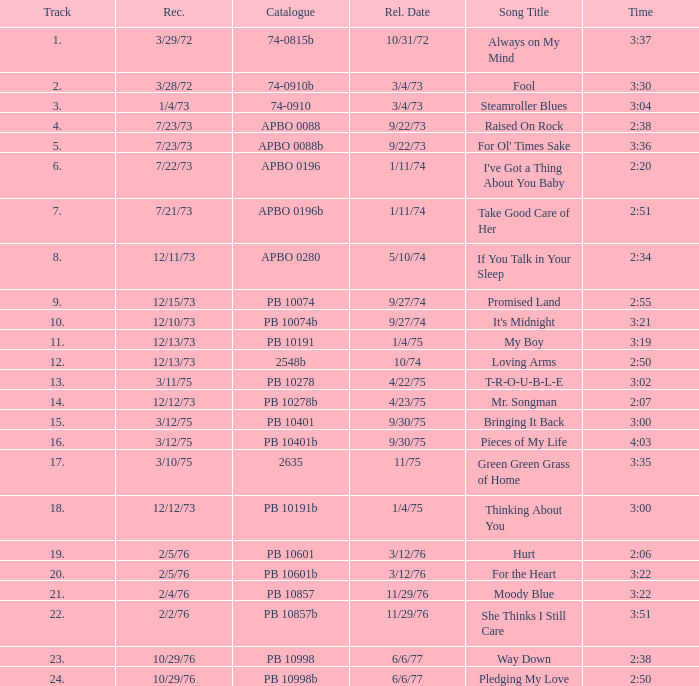Tell me the time for 6/6/77 release date and song title of way down 2:38. 